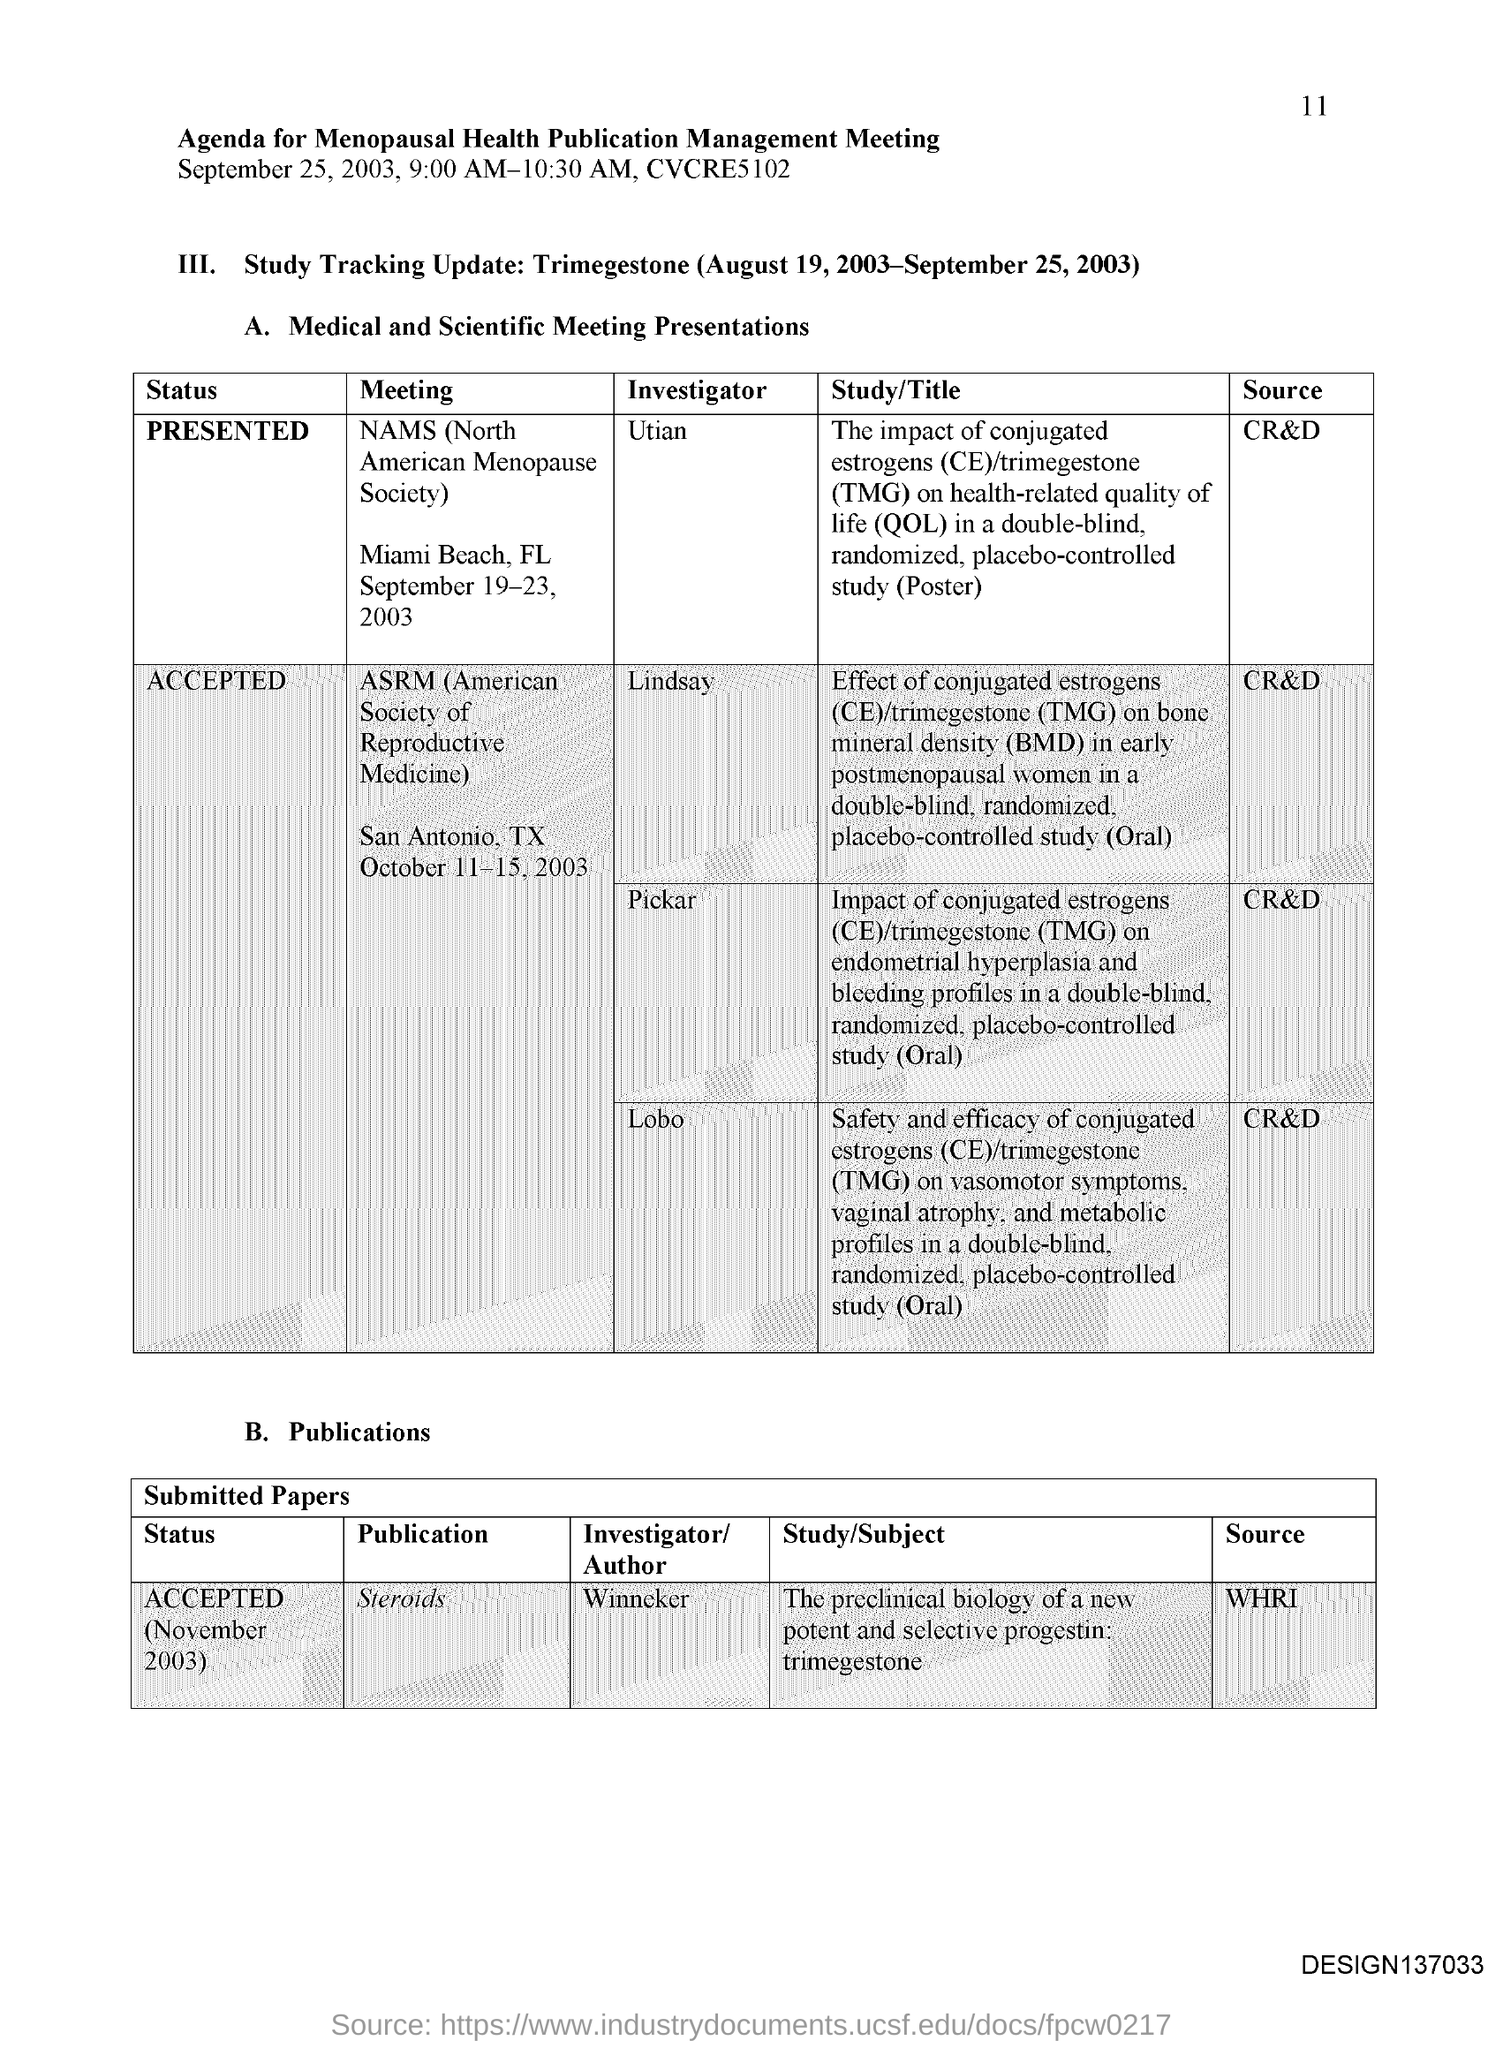Mention a couple of crucial points in this snapshot. The location of the meeting of NAMS (North American Menopause Society) is Miami Beach, Florida. The Meeting known as NAMS (North American Menopause Society) is scheduled to take place from September 19-23. The acronym "NAMS" stands for the North American Menopause Society, a reputable organization dedicated to the study and support of women experiencing menopause. The Menopausal Health Publication Management Meeting was held on September 25, 2003 from 9:00 AM to 10:30 AM. The Menopausal Health Publication Management Meeting will be held from 9:00 AM to 10:30 AM. 